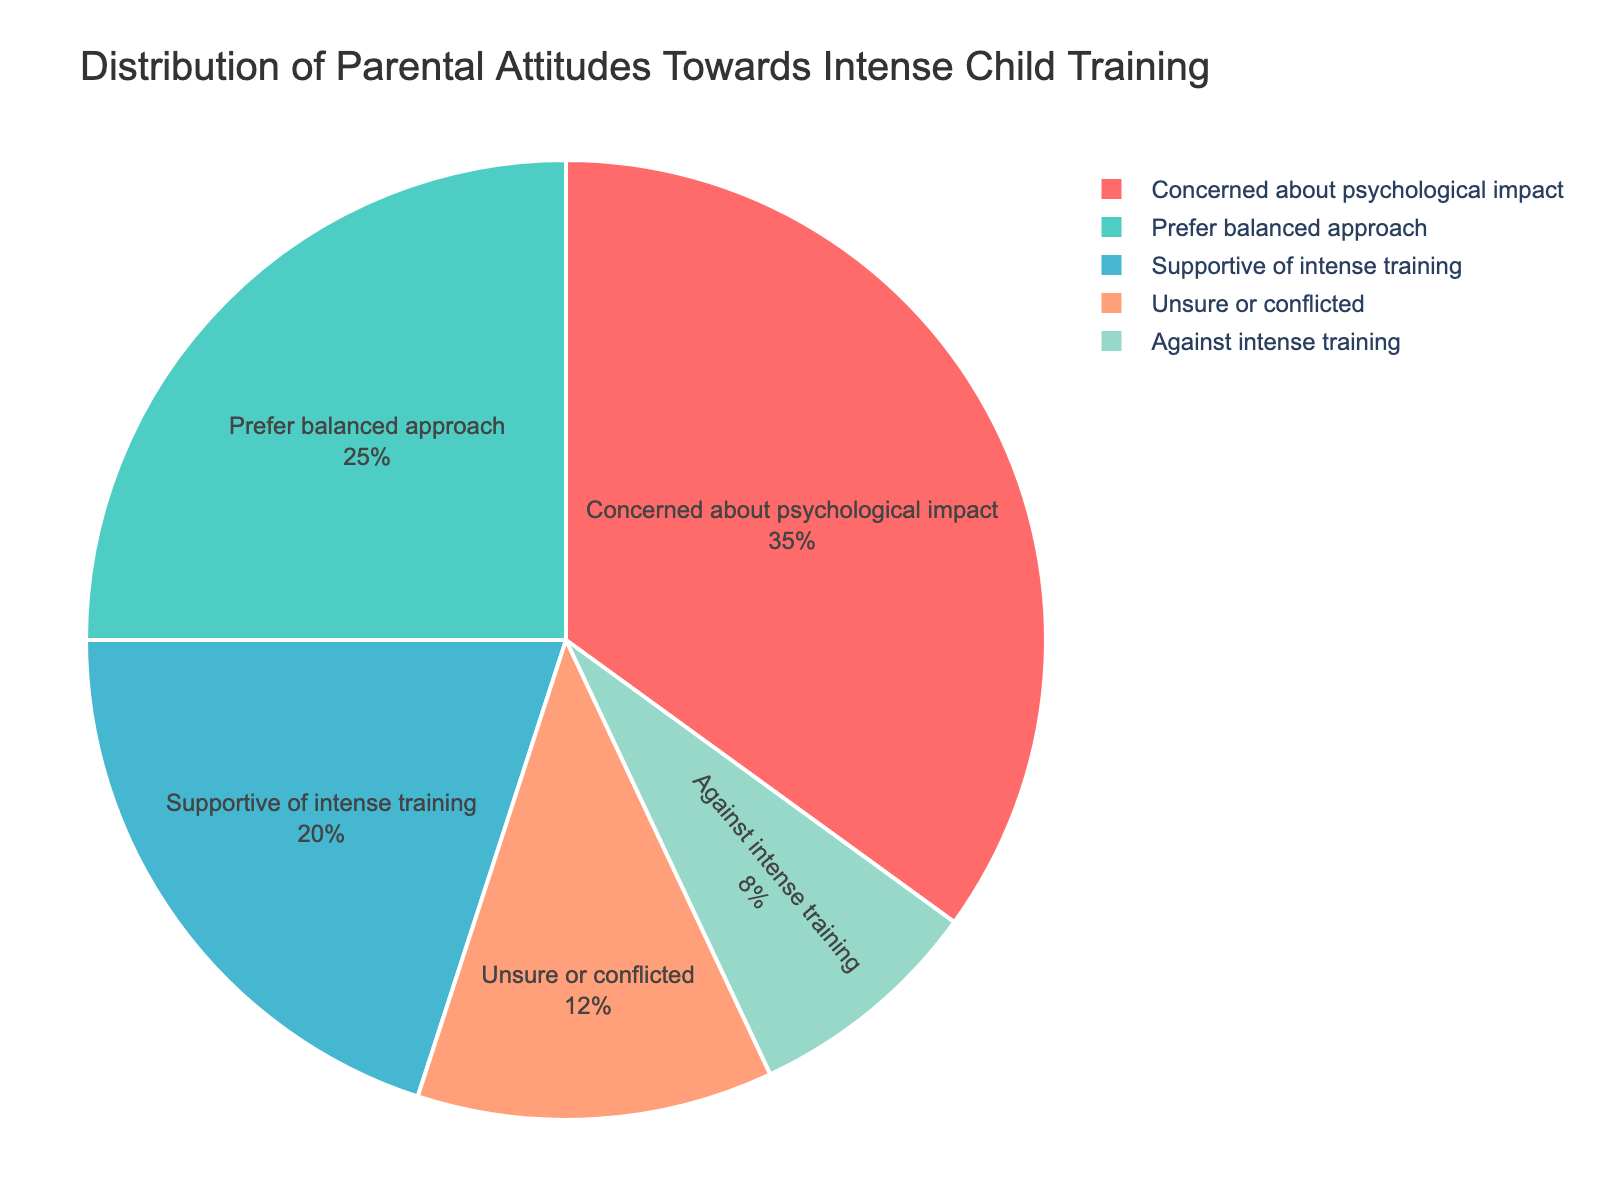What is the largest percentage among parental attitudes towards intense child training? To find the largest percentage, visually identify the largest segment in the pie chart, labeled "Concerned about psychological impact" with a percentage of 35%.
Answer: 35% Which group has the lowest percentage and what is it? Look at the segments and find the smallest one, which is labeled "Against intense training" with a percentage of 8%.
Answer: 8% How do the percentages of "Supportive of intense training" and "Prefer balanced approach" compare? Compare the segment sizes for both categories. "Supportive of intense training" is 20% and "Prefer balanced approach" is 25%. Thus, "Supportive" is 5% less than "Prefer balanced approach."
Answer: Prefer balanced approach is 5% more What is the total percentage of parents who are either "Unsure or conflicted" or "Against intense training"? Add the percentages for "Unsure or conflicted" (12%) and "Against intense training" (8%). 12% + 8% = 20%.
Answer: 20% What percentage of parents are supportive of intense training compared to those concerned about its psychological impact? Identify the segments' percentages: "Supportive of intense training" is 20% and "Concerned about psychological impact" is 35%. Hence, the supportive group is 15% less.
Answer: 15% less If the groups "Concerned about psychological impact" and "Prefer balanced approach" are combined, what will their total percentage be? Sum the percentages of the two groups: 35% + 25% = 60%.
Answer: 60% What’s the difference in percentage between those who are "Unsure or conflicted" and those who "Prefer balanced approach"? Subtract the percentage of "Unsure or conflicted" (12%) from "Prefer balanced approach" (25%). 25% - 12% = 13%.
Answer: 13% What color represents the group "Prefer balanced approach"? Look at the segments and identify the color of the segment labeled "Prefer balanced approach," which is light blue.
Answer: Light blue Which attitude is represented by the green segment? Identify the green segment in the pie chart and match it with its label, which is "Supportive of intense training."
Answer: Supportive of intense training How many groups have a percentage of at least 20%? Identify the segments with percentages of at least 20%: "Concerned about psychological impact" (35%), "Prefer balanced approach" (25%), and "Supportive of intense training" (20%). There are three such groups.
Answer: 3 